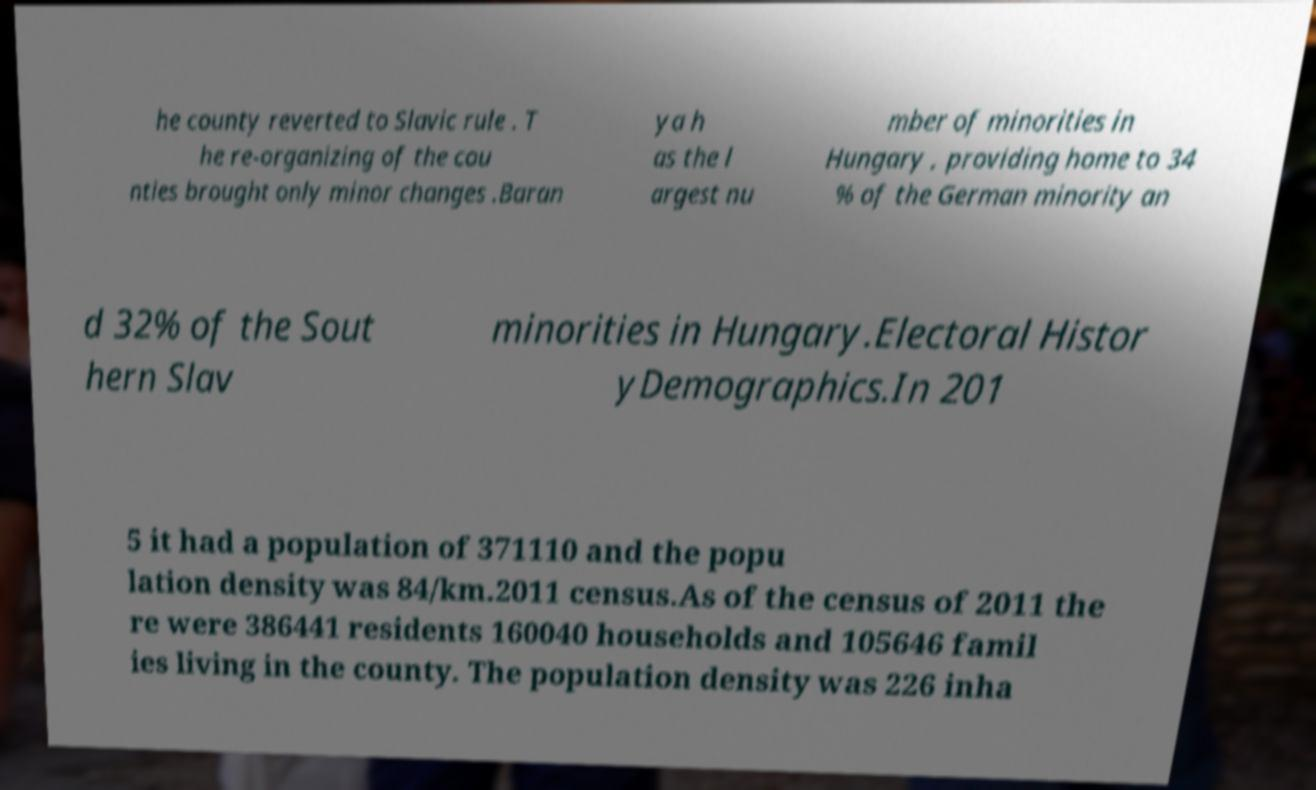Can you read and provide the text displayed in the image?This photo seems to have some interesting text. Can you extract and type it out for me? he county reverted to Slavic rule . T he re-organizing of the cou nties brought only minor changes .Baran ya h as the l argest nu mber of minorities in Hungary , providing home to 34 % of the German minority an d 32% of the Sout hern Slav minorities in Hungary.Electoral Histor yDemographics.In 201 5 it had a population of 371110 and the popu lation density was 84/km.2011 census.As of the census of 2011 the re were 386441 residents 160040 households and 105646 famil ies living in the county. The population density was 226 inha 